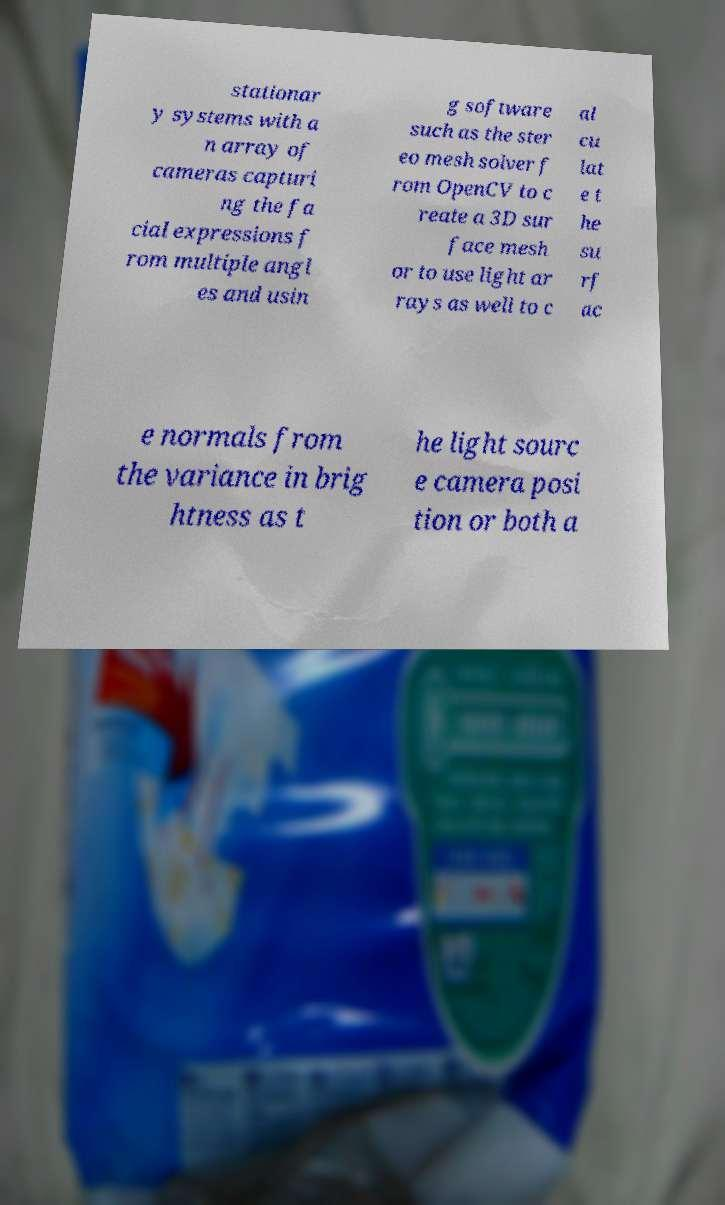Could you assist in decoding the text presented in this image and type it out clearly? stationar y systems with a n array of cameras capturi ng the fa cial expressions f rom multiple angl es and usin g software such as the ster eo mesh solver f rom OpenCV to c reate a 3D sur face mesh or to use light ar rays as well to c al cu lat e t he su rf ac e normals from the variance in brig htness as t he light sourc e camera posi tion or both a 